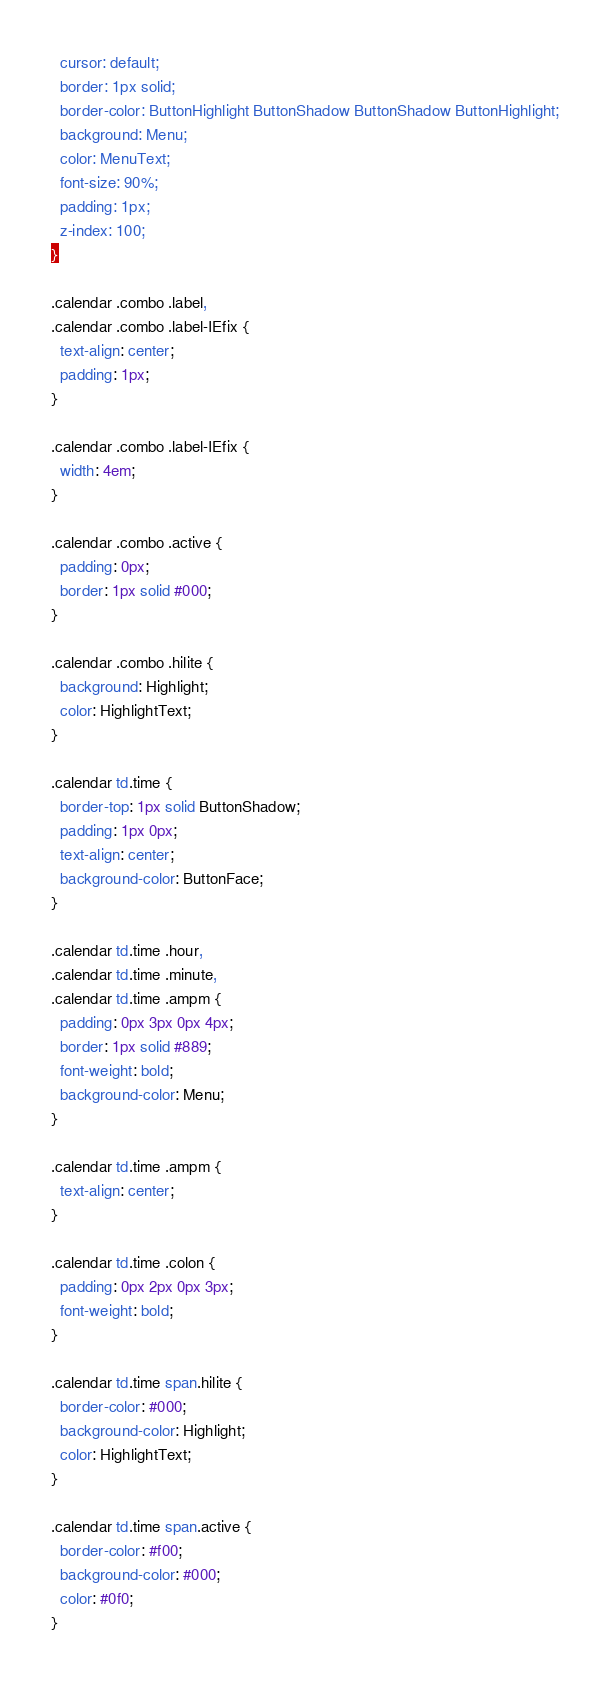Convert code to text. <code><loc_0><loc_0><loc_500><loc_500><_CSS_>  cursor: default;
  border: 1px solid;
  border-color: ButtonHighlight ButtonShadow ButtonShadow ButtonHighlight;
  background: Menu;
  color: MenuText;
  font-size: 90%;
  padding: 1px;
  z-index: 100;
}

.calendar .combo .label,
.calendar .combo .label-IEfix {
  text-align: center;
  padding: 1px;
}

.calendar .combo .label-IEfix {
  width: 4em;
}

.calendar .combo .active {
  padding: 0px;
  border: 1px solid #000;
}

.calendar .combo .hilite {
  background: Highlight;
  color: HighlightText;
}

.calendar td.time {
  border-top: 1px solid ButtonShadow;
  padding: 1px 0px;
  text-align: center;
  background-color: ButtonFace;
}

.calendar td.time .hour,
.calendar td.time .minute,
.calendar td.time .ampm {
  padding: 0px 3px 0px 4px;
  border: 1px solid #889;
  font-weight: bold;
  background-color: Menu;
}

.calendar td.time .ampm {
  text-align: center;
}

.calendar td.time .colon {
  padding: 0px 2px 0px 3px;
  font-weight: bold;
}

.calendar td.time span.hilite {
  border-color: #000;
  background-color: Highlight;
  color: HighlightText;
}

.calendar td.time span.active {
  border-color: #f00;
  background-color: #000;
  color: #0f0;
}
</code> 